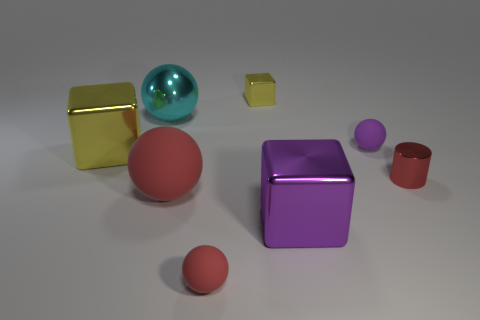Does the metallic cylinder have the same size as the yellow block on the left side of the tiny yellow object?
Give a very brief answer. No. There is a shiny block that is behind the block to the left of the tiny shiny cube; how big is it?
Ensure brevity in your answer.  Small. What is the size of the yellow block on the right side of the large object behind the small ball to the right of the small yellow thing?
Keep it short and to the point. Small. There is a big red object to the left of the big metallic block that is in front of the cylinder in front of the cyan shiny sphere; what is its shape?
Provide a succinct answer. Sphere. Are there more small yellow metallic blocks that are behind the tiny shiny cylinder than big blue metallic cylinders?
Your answer should be very brief. Yes. Are there any large cyan things that have the same shape as the red metallic object?
Provide a succinct answer. No. Are the big red thing and the red object right of the tiny purple object made of the same material?
Keep it short and to the point. No. What is the color of the small block?
Keep it short and to the point. Yellow. There is a large sphere that is in front of the yellow metallic object in front of the tiny purple object; what number of purple things are left of it?
Ensure brevity in your answer.  0. There is a big purple cube; are there any cyan spheres to the right of it?
Your response must be concise. No. 